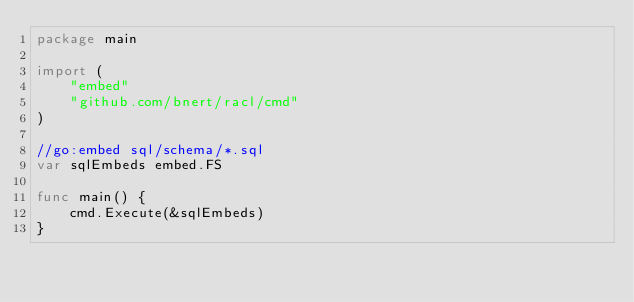<code> <loc_0><loc_0><loc_500><loc_500><_Go_>package main

import (
    "embed"
    "github.com/bnert/racl/cmd"
)

//go:embed sql/schema/*.sql
var sqlEmbeds embed.FS

func main() {
    cmd.Execute(&sqlEmbeds)
}
</code> 